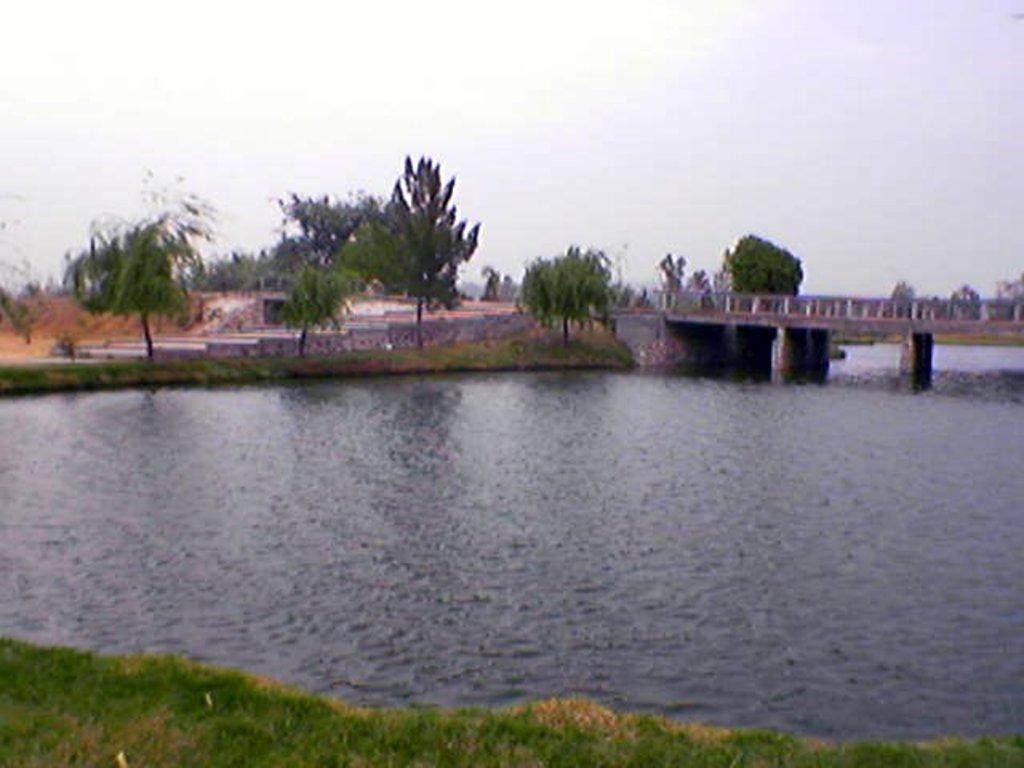What body of water is present in the image? There is a lake in the image. What type of terrain surrounds the lake? There is grass on the ground. How can someone cross the lake in the image? There is a bridge over the lake. What can be seen in the background of the image? There are trees and the sky visible in the background of the image. What type of cork can be seen floating on the lake in the image? There is no cork present in the image; it is a lake surrounded by grass, trees, and a bridge. 